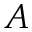<formula> <loc_0><loc_0><loc_500><loc_500>A</formula> 